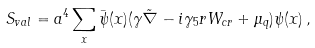<formula> <loc_0><loc_0><loc_500><loc_500>S _ { v a l } = a ^ { 4 } \sum _ { x } \bar { \psi } ( x ) ( \gamma \tilde { \nabla } - i \gamma _ { 5 } r W _ { c r } + \mu _ { q } ) \psi ( x ) \, ,</formula> 